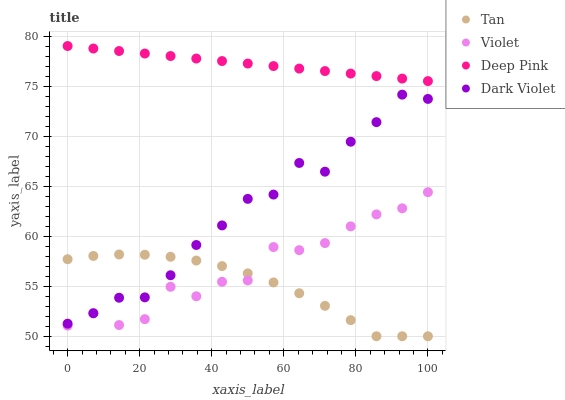Does Tan have the minimum area under the curve?
Answer yes or no. Yes. Does Deep Pink have the maximum area under the curve?
Answer yes or no. Yes. Does Dark Violet have the minimum area under the curve?
Answer yes or no. No. Does Dark Violet have the maximum area under the curve?
Answer yes or no. No. Is Deep Pink the smoothest?
Answer yes or no. Yes. Is Violet the roughest?
Answer yes or no. Yes. Is Dark Violet the smoothest?
Answer yes or no. No. Is Dark Violet the roughest?
Answer yes or no. No. Does Tan have the lowest value?
Answer yes or no. Yes. Does Dark Violet have the lowest value?
Answer yes or no. No. Does Deep Pink have the highest value?
Answer yes or no. Yes. Does Dark Violet have the highest value?
Answer yes or no. No. Is Violet less than Deep Pink?
Answer yes or no. Yes. Is Deep Pink greater than Violet?
Answer yes or no. Yes. Does Tan intersect Dark Violet?
Answer yes or no. Yes. Is Tan less than Dark Violet?
Answer yes or no. No. Is Tan greater than Dark Violet?
Answer yes or no. No. Does Violet intersect Deep Pink?
Answer yes or no. No. 